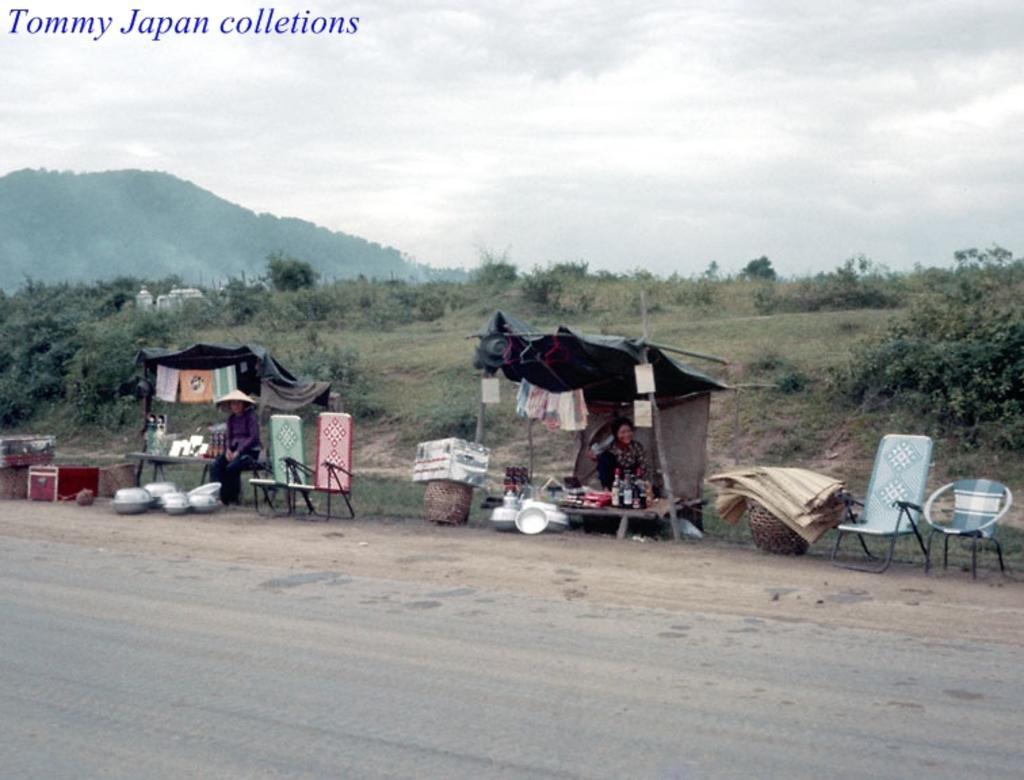Describe this image in one or two sentences. In the center of the image we can see two persons are sitting under the tents. And we can see chairs, clothes, barrels, containers, boxes, tables, banners, toys, mirrors, bottles, mats and a few other objects. In the bottom of the image, there is a road. In the background we can see the sky, clouds, trees, grass, one building, hill etc. On the top left side of the image, we can see some text. 